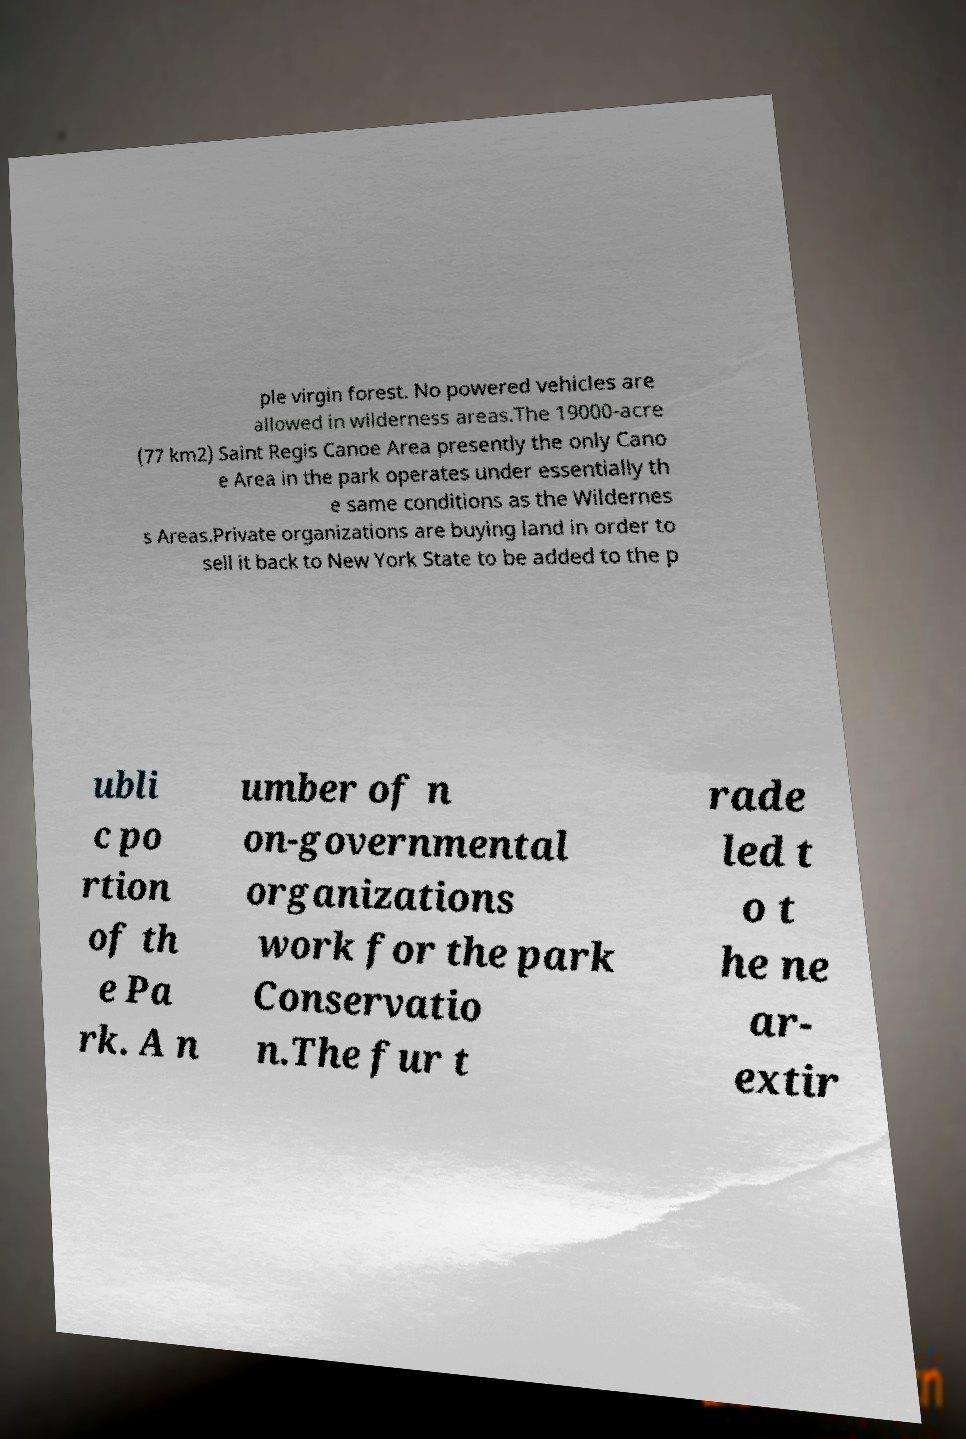Could you extract and type out the text from this image? ple virgin forest. No powered vehicles are allowed in wilderness areas.The 19000-acre (77 km2) Saint Regis Canoe Area presently the only Cano e Area in the park operates under essentially th e same conditions as the Wildernes s Areas.Private organizations are buying land in order to sell it back to New York State to be added to the p ubli c po rtion of th e Pa rk. A n umber of n on-governmental organizations work for the park Conservatio n.The fur t rade led t o t he ne ar- extir 